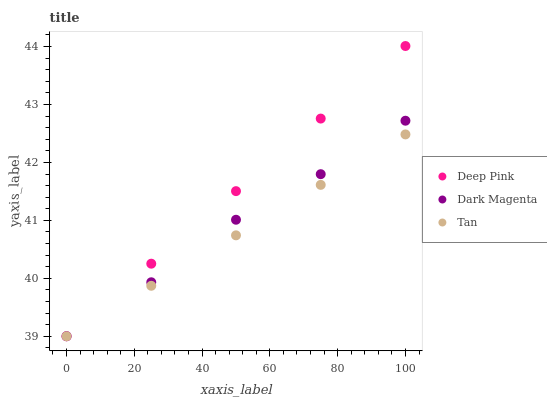Does Tan have the minimum area under the curve?
Answer yes or no. Yes. Does Deep Pink have the maximum area under the curve?
Answer yes or no. Yes. Does Dark Magenta have the minimum area under the curve?
Answer yes or no. No. Does Dark Magenta have the maximum area under the curve?
Answer yes or no. No. Is Tan the smoothest?
Answer yes or no. Yes. Is Dark Magenta the roughest?
Answer yes or no. Yes. Is Deep Pink the smoothest?
Answer yes or no. No. Is Deep Pink the roughest?
Answer yes or no. No. Does Tan have the lowest value?
Answer yes or no. Yes. Does Deep Pink have the highest value?
Answer yes or no. Yes. Does Dark Magenta have the highest value?
Answer yes or no. No. Does Deep Pink intersect Tan?
Answer yes or no. Yes. Is Deep Pink less than Tan?
Answer yes or no. No. Is Deep Pink greater than Tan?
Answer yes or no. No. 